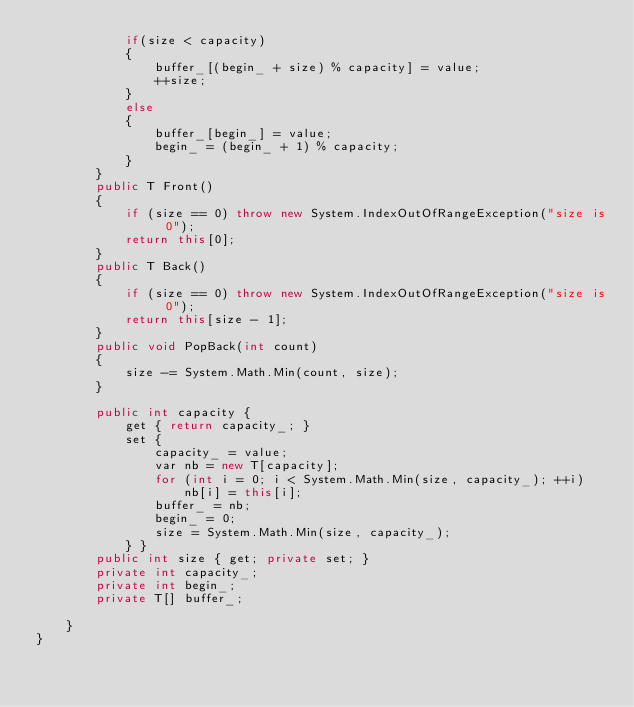<code> <loc_0><loc_0><loc_500><loc_500><_C#_>            if(size < capacity)
            {
                buffer_[(begin_ + size) % capacity] = value;
                ++size;
            }
            else
            {
                buffer_[begin_] = value;
                begin_ = (begin_ + 1) % capacity;
            }
        }
        public T Front()
        {
            if (size == 0) throw new System.IndexOutOfRangeException("size is 0");
            return this[0];
        }
        public T Back()
        {
            if (size == 0) throw new System.IndexOutOfRangeException("size is 0");
            return this[size - 1];
        }
        public void PopBack(int count)
        {
            size -= System.Math.Min(count, size);
        }

        public int capacity {
            get { return capacity_; }
            set {
                capacity_ = value;
                var nb = new T[capacity];
                for (int i = 0; i < System.Math.Min(size, capacity_); ++i)
                    nb[i] = this[i];
                buffer_ = nb;
                begin_ = 0;
                size = System.Math.Min(size, capacity_);
            } }
        public int size { get; private set; }
        private int capacity_;
        private int begin_;
        private T[] buffer_;

    }
}
</code> 